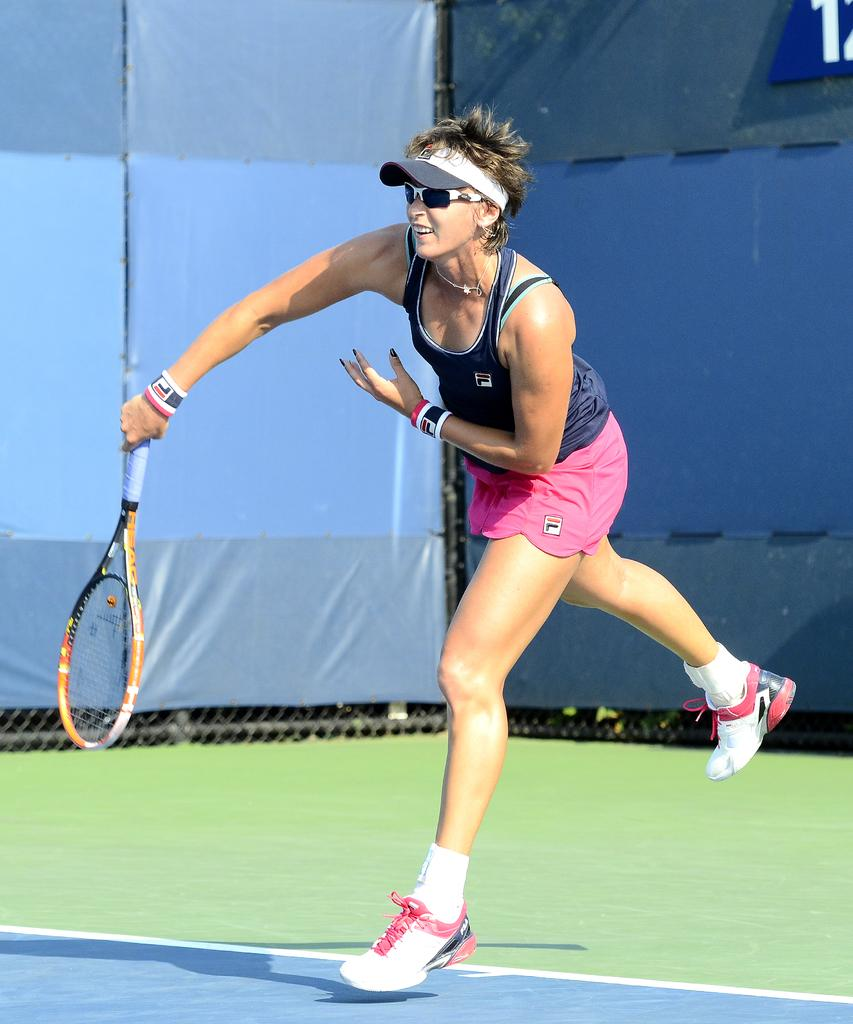Who is present in the image? There is a woman in the image. What is the woman's position in relation to the ground? The woman is standing on the ground. What can be seen in the background of the image? There is a fence in the background of the image. What type of trousers is the hen wearing in the image? There is no hen present in the image, and therefore no trousers to consider. 